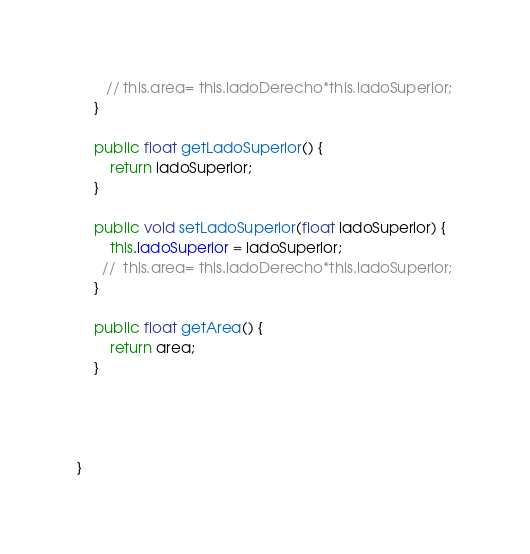Convert code to text. <code><loc_0><loc_0><loc_500><loc_500><_Java_>       // this.area= this.ladoDerecho*this.ladoSuperior;
    }

    public float getLadoSuperior() {
        return ladoSuperior;
    }

    public void setLadoSuperior(float ladoSuperior) {
        this.ladoSuperior = ladoSuperior;
      //  this.area= this.ladoDerecho*this.ladoSuperior;
    }

    public float getArea() {
        return area;
    }

    
    
    
}
</code> 